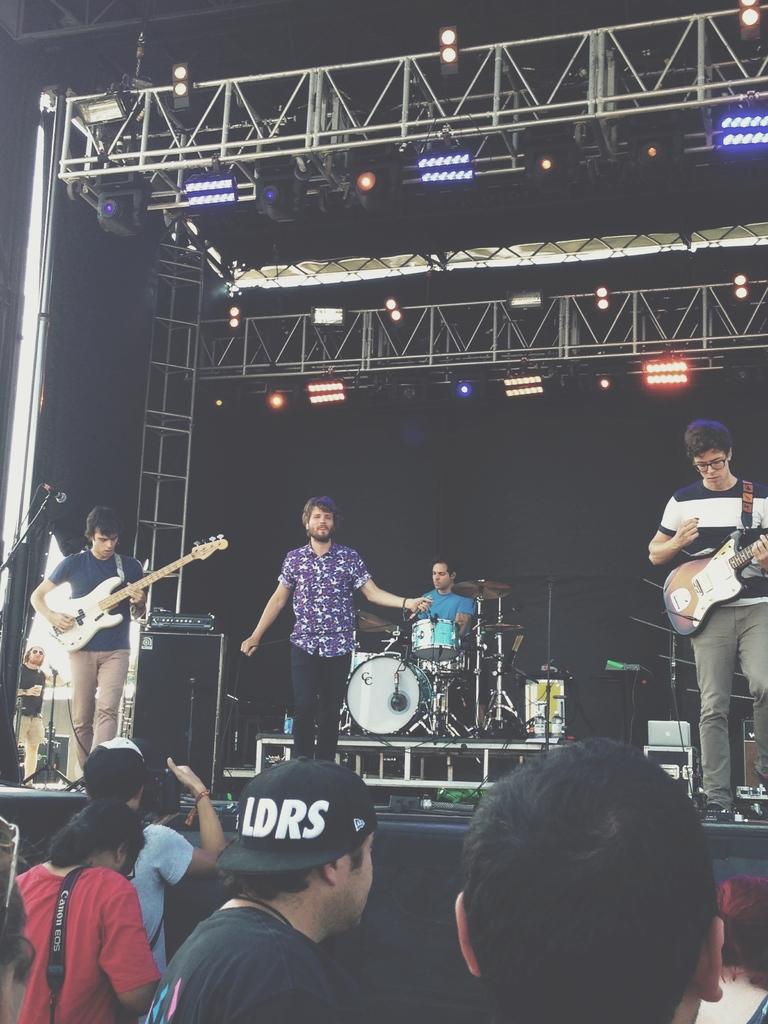Describe this image in one or two sentences. In this image I can see the people standing on the stage and playing musical instruments. Among them two people are playing guitar and one is playing drum set. In front of them there are people standing and taking the pictures. 